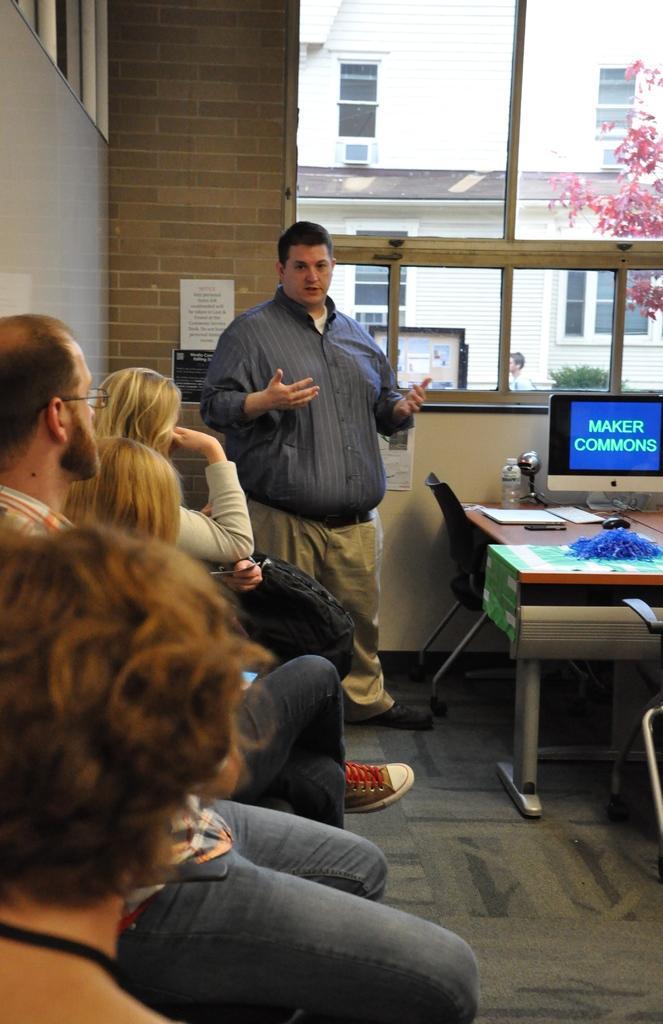How would you summarize this image in a sentence or two? In this image In the middle there is a man he wear shirt, trouser and shoes. On the right there is a table,chair, bottle, system and mouse. In the left there are some people sitting. In the background there is a wall, window, tree, building and plant. 